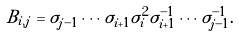Convert formula to latex. <formula><loc_0><loc_0><loc_500><loc_500>B _ { i , j } = \sigma _ { j - 1 } \cdots \sigma _ { i + 1 } \sigma _ { i } ^ { 2 } \sigma _ { i + 1 } ^ { - 1 } \cdots \sigma _ { j - 1 } ^ { - 1 } .</formula> 